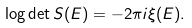<formula> <loc_0><loc_0><loc_500><loc_500>\log \det S ( E ) = - 2 \pi i \xi ( E ) .</formula> 